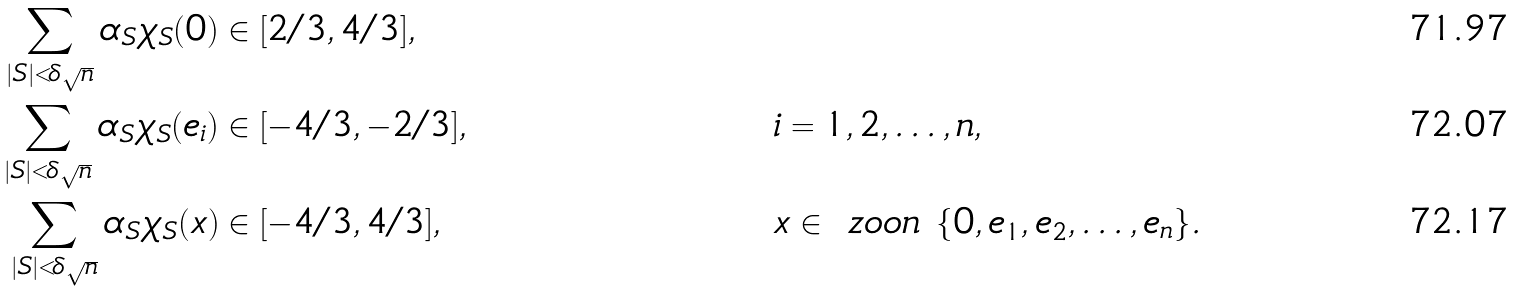<formula> <loc_0><loc_0><loc_500><loc_500>\sum _ { | S | < \delta \sqrt { n } } \alpha _ { S } \chi _ { S } ( 0 ) & \in [ 2 / 3 , 4 / 3 ] , \\ \sum _ { | S | < \delta \sqrt { n } } \alpha _ { S } \chi _ { S } ( e _ { i } ) & \in [ - 4 / 3 , - 2 / 3 ] , & & i = 1 , 2 , \dots , n , \\ \sum _ { | S | < \delta \sqrt { n } } \alpha _ { S } \chi _ { S } ( x ) & \in [ - 4 / 3 , 4 / 3 ] , & & x \in \ z o o n \ \{ 0 , e _ { 1 } , e _ { 2 } , \dots , e _ { n } \} .</formula> 